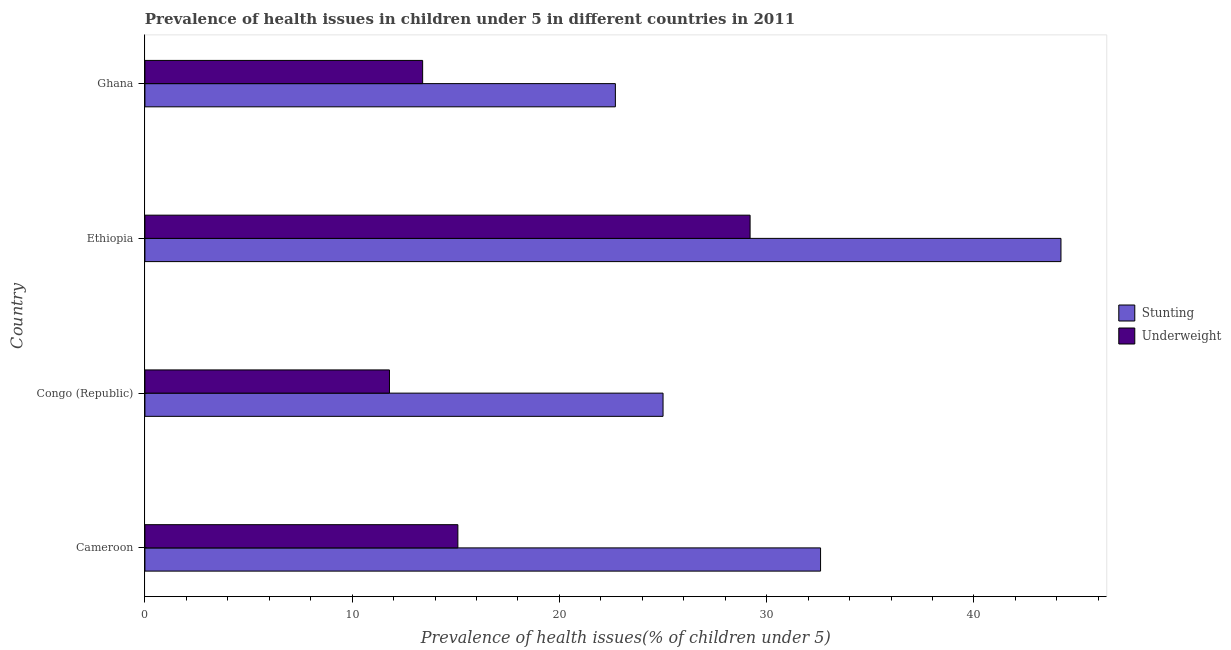How many different coloured bars are there?
Offer a very short reply. 2. How many groups of bars are there?
Ensure brevity in your answer.  4. Are the number of bars per tick equal to the number of legend labels?
Make the answer very short. Yes. How many bars are there on the 2nd tick from the top?
Offer a terse response. 2. How many bars are there on the 4th tick from the bottom?
Make the answer very short. 2. What is the label of the 4th group of bars from the top?
Provide a succinct answer. Cameroon. In how many cases, is the number of bars for a given country not equal to the number of legend labels?
Make the answer very short. 0. What is the percentage of underweight children in Cameroon?
Offer a terse response. 15.1. Across all countries, what is the maximum percentage of underweight children?
Offer a terse response. 29.2. Across all countries, what is the minimum percentage of underweight children?
Ensure brevity in your answer.  11.8. In which country was the percentage of stunted children maximum?
Make the answer very short. Ethiopia. In which country was the percentage of underweight children minimum?
Your response must be concise. Congo (Republic). What is the total percentage of underweight children in the graph?
Give a very brief answer. 69.5. What is the difference between the percentage of underweight children in Cameroon and that in Ghana?
Ensure brevity in your answer.  1.7. What is the difference between the percentage of stunted children in Cameroon and the percentage of underweight children in Ghana?
Provide a short and direct response. 19.2. What is the average percentage of stunted children per country?
Offer a terse response. 31.12. What is the difference between the percentage of stunted children and percentage of underweight children in Cameroon?
Make the answer very short. 17.5. In how many countries, is the percentage of underweight children greater than 4 %?
Offer a terse response. 4. What is the ratio of the percentage of stunted children in Congo (Republic) to that in Ghana?
Your response must be concise. 1.1. In how many countries, is the percentage of underweight children greater than the average percentage of underweight children taken over all countries?
Offer a terse response. 1. What does the 1st bar from the top in Congo (Republic) represents?
Your answer should be compact. Underweight. What does the 2nd bar from the bottom in Ethiopia represents?
Your response must be concise. Underweight. Are all the bars in the graph horizontal?
Offer a very short reply. Yes. How many countries are there in the graph?
Your response must be concise. 4. What is the difference between two consecutive major ticks on the X-axis?
Offer a very short reply. 10. Does the graph contain any zero values?
Offer a terse response. No. Does the graph contain grids?
Give a very brief answer. No. What is the title of the graph?
Your answer should be very brief. Prevalence of health issues in children under 5 in different countries in 2011. What is the label or title of the X-axis?
Make the answer very short. Prevalence of health issues(% of children under 5). What is the label or title of the Y-axis?
Provide a short and direct response. Country. What is the Prevalence of health issues(% of children under 5) of Stunting in Cameroon?
Offer a terse response. 32.6. What is the Prevalence of health issues(% of children under 5) in Underweight in Cameroon?
Provide a succinct answer. 15.1. What is the Prevalence of health issues(% of children under 5) of Stunting in Congo (Republic)?
Provide a short and direct response. 25. What is the Prevalence of health issues(% of children under 5) in Underweight in Congo (Republic)?
Your answer should be very brief. 11.8. What is the Prevalence of health issues(% of children under 5) in Stunting in Ethiopia?
Offer a very short reply. 44.2. What is the Prevalence of health issues(% of children under 5) of Underweight in Ethiopia?
Give a very brief answer. 29.2. What is the Prevalence of health issues(% of children under 5) in Stunting in Ghana?
Keep it short and to the point. 22.7. What is the Prevalence of health issues(% of children under 5) of Underweight in Ghana?
Provide a succinct answer. 13.4. Across all countries, what is the maximum Prevalence of health issues(% of children under 5) in Stunting?
Make the answer very short. 44.2. Across all countries, what is the maximum Prevalence of health issues(% of children under 5) of Underweight?
Provide a succinct answer. 29.2. Across all countries, what is the minimum Prevalence of health issues(% of children under 5) in Stunting?
Your response must be concise. 22.7. Across all countries, what is the minimum Prevalence of health issues(% of children under 5) of Underweight?
Your answer should be very brief. 11.8. What is the total Prevalence of health issues(% of children under 5) in Stunting in the graph?
Provide a succinct answer. 124.5. What is the total Prevalence of health issues(% of children under 5) in Underweight in the graph?
Offer a terse response. 69.5. What is the difference between the Prevalence of health issues(% of children under 5) in Underweight in Cameroon and that in Ethiopia?
Keep it short and to the point. -14.1. What is the difference between the Prevalence of health issues(% of children under 5) in Stunting in Cameroon and that in Ghana?
Your answer should be very brief. 9.9. What is the difference between the Prevalence of health issues(% of children under 5) of Stunting in Congo (Republic) and that in Ethiopia?
Give a very brief answer. -19.2. What is the difference between the Prevalence of health issues(% of children under 5) of Underweight in Congo (Republic) and that in Ethiopia?
Offer a terse response. -17.4. What is the difference between the Prevalence of health issues(% of children under 5) in Stunting in Congo (Republic) and that in Ghana?
Your response must be concise. 2.3. What is the difference between the Prevalence of health issues(% of children under 5) in Underweight in Congo (Republic) and that in Ghana?
Your answer should be compact. -1.6. What is the difference between the Prevalence of health issues(% of children under 5) of Stunting in Ethiopia and that in Ghana?
Make the answer very short. 21.5. What is the difference between the Prevalence of health issues(% of children under 5) of Underweight in Ethiopia and that in Ghana?
Give a very brief answer. 15.8. What is the difference between the Prevalence of health issues(% of children under 5) of Stunting in Cameroon and the Prevalence of health issues(% of children under 5) of Underweight in Congo (Republic)?
Your response must be concise. 20.8. What is the difference between the Prevalence of health issues(% of children under 5) of Stunting in Cameroon and the Prevalence of health issues(% of children under 5) of Underweight in Ethiopia?
Your response must be concise. 3.4. What is the difference between the Prevalence of health issues(% of children under 5) in Stunting in Cameroon and the Prevalence of health issues(% of children under 5) in Underweight in Ghana?
Your answer should be compact. 19.2. What is the difference between the Prevalence of health issues(% of children under 5) in Stunting in Congo (Republic) and the Prevalence of health issues(% of children under 5) in Underweight in Ethiopia?
Keep it short and to the point. -4.2. What is the difference between the Prevalence of health issues(% of children under 5) of Stunting in Ethiopia and the Prevalence of health issues(% of children under 5) of Underweight in Ghana?
Give a very brief answer. 30.8. What is the average Prevalence of health issues(% of children under 5) in Stunting per country?
Give a very brief answer. 31.12. What is the average Prevalence of health issues(% of children under 5) in Underweight per country?
Your answer should be compact. 17.38. What is the difference between the Prevalence of health issues(% of children under 5) in Stunting and Prevalence of health issues(% of children under 5) in Underweight in Ghana?
Ensure brevity in your answer.  9.3. What is the ratio of the Prevalence of health issues(% of children under 5) of Stunting in Cameroon to that in Congo (Republic)?
Offer a terse response. 1.3. What is the ratio of the Prevalence of health issues(% of children under 5) in Underweight in Cameroon to that in Congo (Republic)?
Ensure brevity in your answer.  1.28. What is the ratio of the Prevalence of health issues(% of children under 5) of Stunting in Cameroon to that in Ethiopia?
Offer a terse response. 0.74. What is the ratio of the Prevalence of health issues(% of children under 5) in Underweight in Cameroon to that in Ethiopia?
Offer a very short reply. 0.52. What is the ratio of the Prevalence of health issues(% of children under 5) in Stunting in Cameroon to that in Ghana?
Ensure brevity in your answer.  1.44. What is the ratio of the Prevalence of health issues(% of children under 5) in Underweight in Cameroon to that in Ghana?
Make the answer very short. 1.13. What is the ratio of the Prevalence of health issues(% of children under 5) of Stunting in Congo (Republic) to that in Ethiopia?
Provide a short and direct response. 0.57. What is the ratio of the Prevalence of health issues(% of children under 5) in Underweight in Congo (Republic) to that in Ethiopia?
Your answer should be compact. 0.4. What is the ratio of the Prevalence of health issues(% of children under 5) in Stunting in Congo (Republic) to that in Ghana?
Provide a succinct answer. 1.1. What is the ratio of the Prevalence of health issues(% of children under 5) of Underweight in Congo (Republic) to that in Ghana?
Offer a very short reply. 0.88. What is the ratio of the Prevalence of health issues(% of children under 5) of Stunting in Ethiopia to that in Ghana?
Provide a succinct answer. 1.95. What is the ratio of the Prevalence of health issues(% of children under 5) in Underweight in Ethiopia to that in Ghana?
Give a very brief answer. 2.18. What is the difference between the highest and the second highest Prevalence of health issues(% of children under 5) of Stunting?
Your response must be concise. 11.6. What is the difference between the highest and the lowest Prevalence of health issues(% of children under 5) of Underweight?
Your answer should be very brief. 17.4. 